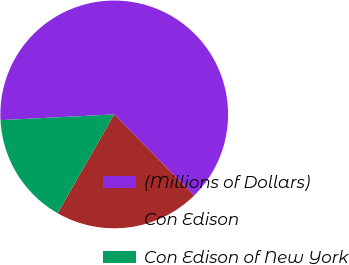Convert chart. <chart><loc_0><loc_0><loc_500><loc_500><pie_chart><fcel>(Millions of Dollars)<fcel>Con Edison<fcel>Con Edison of New York<nl><fcel>63.42%<fcel>20.67%<fcel>15.92%<nl></chart> 